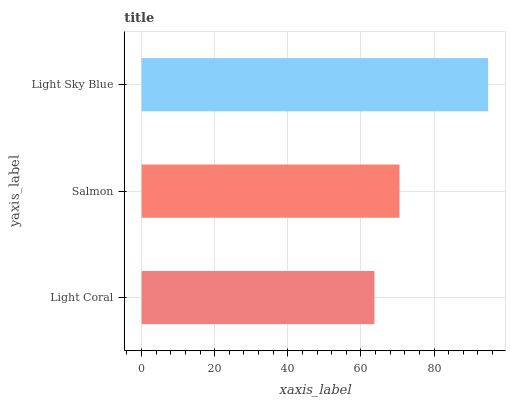Is Light Coral the minimum?
Answer yes or no. Yes. Is Light Sky Blue the maximum?
Answer yes or no. Yes. Is Salmon the minimum?
Answer yes or no. No. Is Salmon the maximum?
Answer yes or no. No. Is Salmon greater than Light Coral?
Answer yes or no. Yes. Is Light Coral less than Salmon?
Answer yes or no. Yes. Is Light Coral greater than Salmon?
Answer yes or no. No. Is Salmon less than Light Coral?
Answer yes or no. No. Is Salmon the high median?
Answer yes or no. Yes. Is Salmon the low median?
Answer yes or no. Yes. Is Light Sky Blue the high median?
Answer yes or no. No. Is Light Sky Blue the low median?
Answer yes or no. No. 